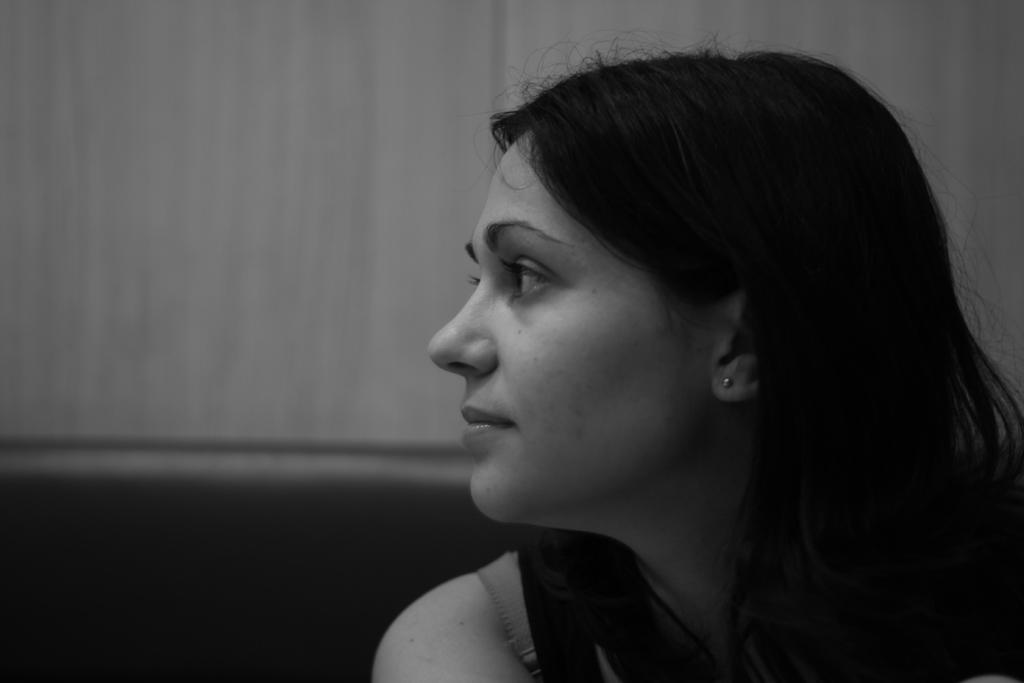What is the color scheme of the image? The image is black and white. Can you describe the main subject of the image? There is a woman in the image. How many fairies are present in the image? There are no fairies present in the image; it only features a woman. What type of books can be seen in the image? There are no books visible in the image; it is a black and white image of a woman. 